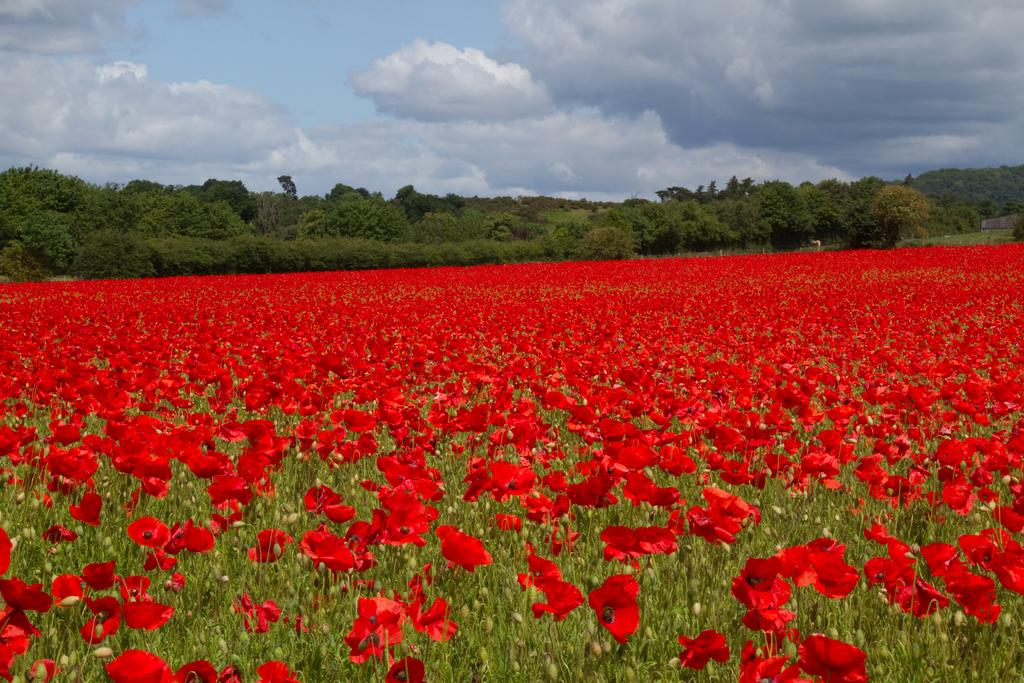What type of plants can be seen in the image? There are flowers and trees in the image. What part of the natural environment is visible in the image? The sky is visible in the image. What type of breakfast is being served on the fork in the image? There is no fork or breakfast present in the image; it features flowers, trees, and the sky. 